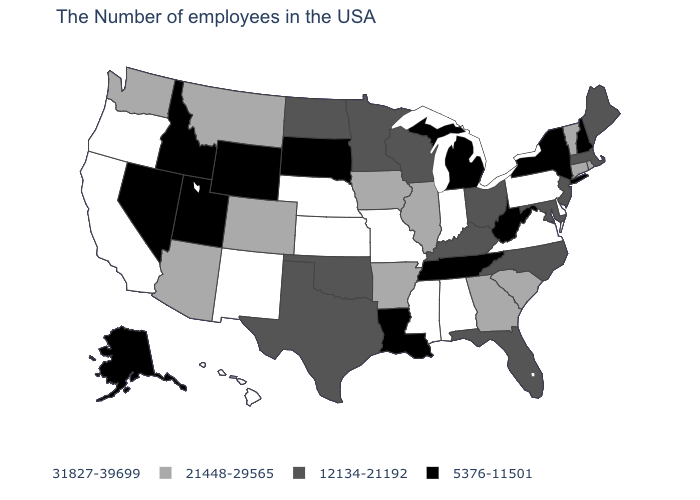What is the value of Wisconsin?
Answer briefly. 12134-21192. Which states have the lowest value in the USA?
Keep it brief. New Hampshire, New York, West Virginia, Michigan, Tennessee, Louisiana, South Dakota, Wyoming, Utah, Idaho, Nevada, Alaska. Does the first symbol in the legend represent the smallest category?
Short answer required. No. Which states have the lowest value in the USA?
Concise answer only. New Hampshire, New York, West Virginia, Michigan, Tennessee, Louisiana, South Dakota, Wyoming, Utah, Idaho, Nevada, Alaska. Is the legend a continuous bar?
Concise answer only. No. Is the legend a continuous bar?
Keep it brief. No. Among the states that border New Mexico , does Arizona have the highest value?
Short answer required. Yes. What is the value of New Mexico?
Be succinct. 31827-39699. How many symbols are there in the legend?
Short answer required. 4. Name the states that have a value in the range 5376-11501?
Be succinct. New Hampshire, New York, West Virginia, Michigan, Tennessee, Louisiana, South Dakota, Wyoming, Utah, Idaho, Nevada, Alaska. Does the map have missing data?
Give a very brief answer. No. Among the states that border Iowa , which have the highest value?
Concise answer only. Missouri, Nebraska. How many symbols are there in the legend?
Give a very brief answer. 4. Among the states that border Oregon , which have the highest value?
Write a very short answer. California. Name the states that have a value in the range 12134-21192?
Answer briefly. Maine, Massachusetts, New Jersey, Maryland, North Carolina, Ohio, Florida, Kentucky, Wisconsin, Minnesota, Oklahoma, Texas, North Dakota. 